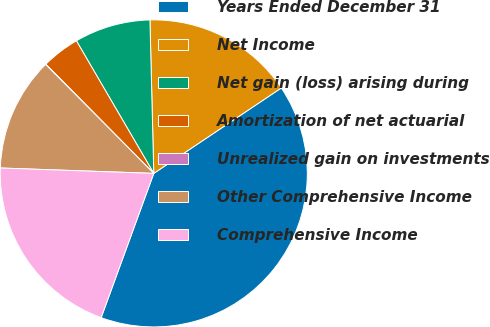Convert chart. <chart><loc_0><loc_0><loc_500><loc_500><pie_chart><fcel>Years Ended December 31<fcel>Net Income<fcel>Net gain (loss) arising during<fcel>Amortization of net actuarial<fcel>Unrealized gain on investments<fcel>Other Comprehensive Income<fcel>Comprehensive Income<nl><fcel>39.96%<fcel>16.0%<fcel>8.01%<fcel>4.01%<fcel>0.02%<fcel>12.0%<fcel>19.99%<nl></chart> 